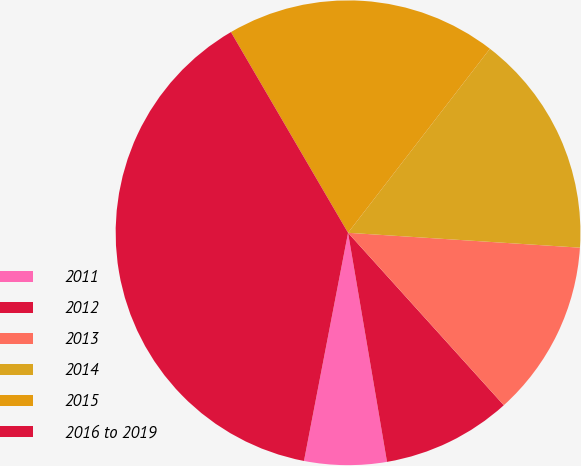<chart> <loc_0><loc_0><loc_500><loc_500><pie_chart><fcel>2011<fcel>2012<fcel>2013<fcel>2014<fcel>2015<fcel>2016 to 2019<nl><fcel>5.72%<fcel>9.01%<fcel>12.29%<fcel>15.57%<fcel>18.86%<fcel>38.56%<nl></chart> 